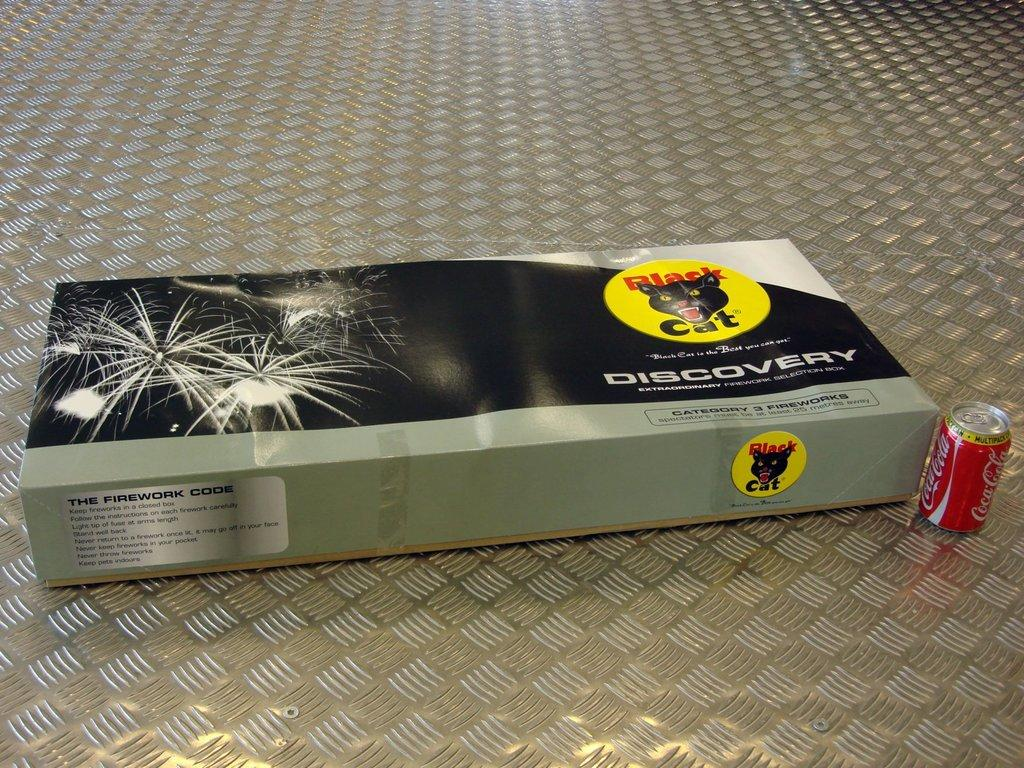<image>
Present a compact description of the photo's key features. A box of black cat fireworks called discovery. 